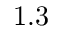<formula> <loc_0><loc_0><loc_500><loc_500>1 . 3</formula> 